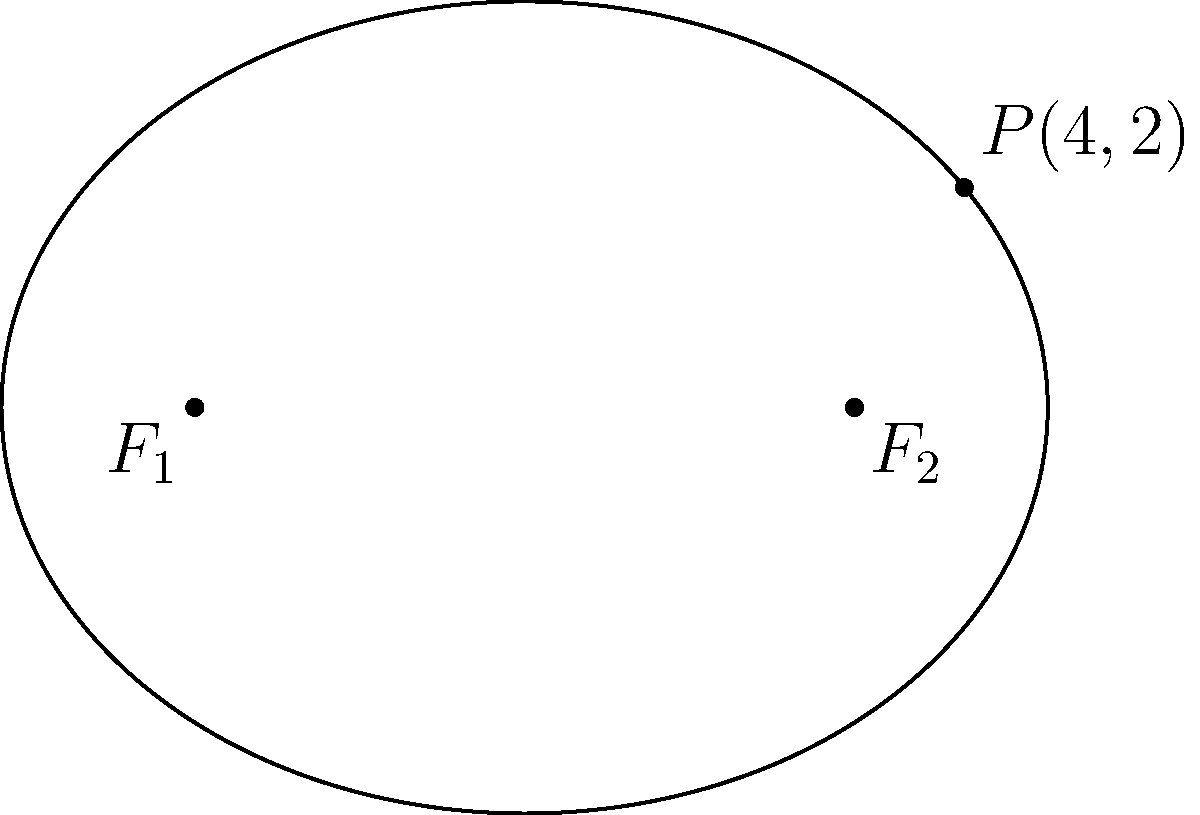In the context of studying visual storytelling in museums, consider an exhibit layout shaped like an ellipse. Given that the foci of this elliptical layout are at $(-3,0)$ and $(3,0)$, and a point $P(4,2)$ lies on the curve, determine the equation of the ellipse. How might this mathematical representation inform the design of exhibits to optimize visitor engagement? To find the equation of the ellipse, we'll follow these steps:

1) The general equation of an ellipse with center at the origin is:
   $$\frac{x^2}{a^2} + \frac{y^2}{b^2} = 1$$
   where $a$ is the length of the semi-major axis and $b$ is the length of the semi-minor axis.

2) The distance between the foci is $2c = 6$, so $c = 3$.

3) We can find $a$ using the point $P(4,2)$ on the ellipse:
   $$a^2 = \frac{(x_P^2 + y_P^2) + \sqrt{(x_P^2 + y_P^2)^2 - 4c^2y_P^2}}{2}$$
   $$a^2 = \frac{(4^2 + 2^2) + \sqrt{(4^2 + 2^2)^2 - 4(3^2)(2^2)}}{2}$$
   $$a^2 = \frac{20 + \sqrt{400 - 144}}{2} = \frac{20 + \sqrt{256}}{2} = \frac{20 + 16}{2} = 18$$
   $$a = \sqrt{18} = 3\sqrt{2}$$

4) We can find $b$ using the relation $a^2 = b^2 + c^2$:
   $$b^2 = a^2 - c^2 = 18 - 9 = 9$$
   $$b = 3$$

5) Substituting these values into the general equation:
   $$\frac{x^2}{(3\sqrt{2})^2} + \frac{y^2}{3^2} = 1$$
   $$\frac{x^2}{18} + \frac{y^2}{9} = 1$$

This mathematical representation can inform exhibit design by:
- Defining the precise shape of the layout
- Helping to calculate optimal viewing distances
- Assisting in the placement of key exhibit elements to maximize visitor flow and engagement
Answer: $$\frac{x^2}{18} + \frac{y^2}{9} = 1$$ 